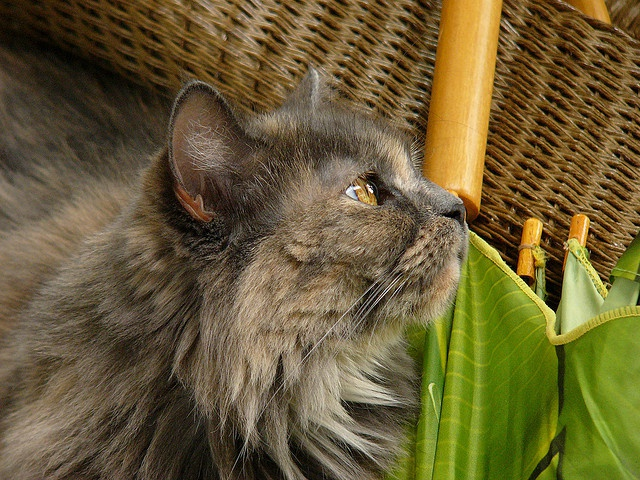Describe the objects in this image and their specific colors. I can see cat in black and gray tones and umbrella in black, olive, and darkgreen tones in this image. 